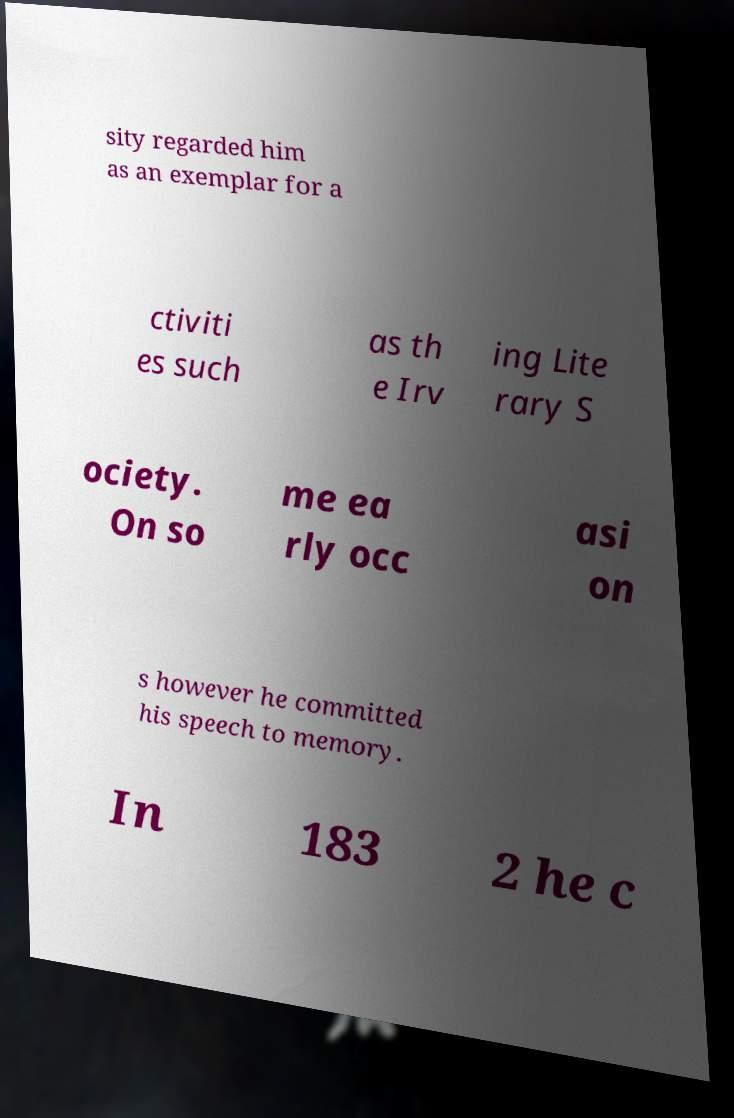Can you accurately transcribe the text from the provided image for me? sity regarded him as an exemplar for a ctiviti es such as th e Irv ing Lite rary S ociety. On so me ea rly occ asi on s however he committed his speech to memory. In 183 2 he c 